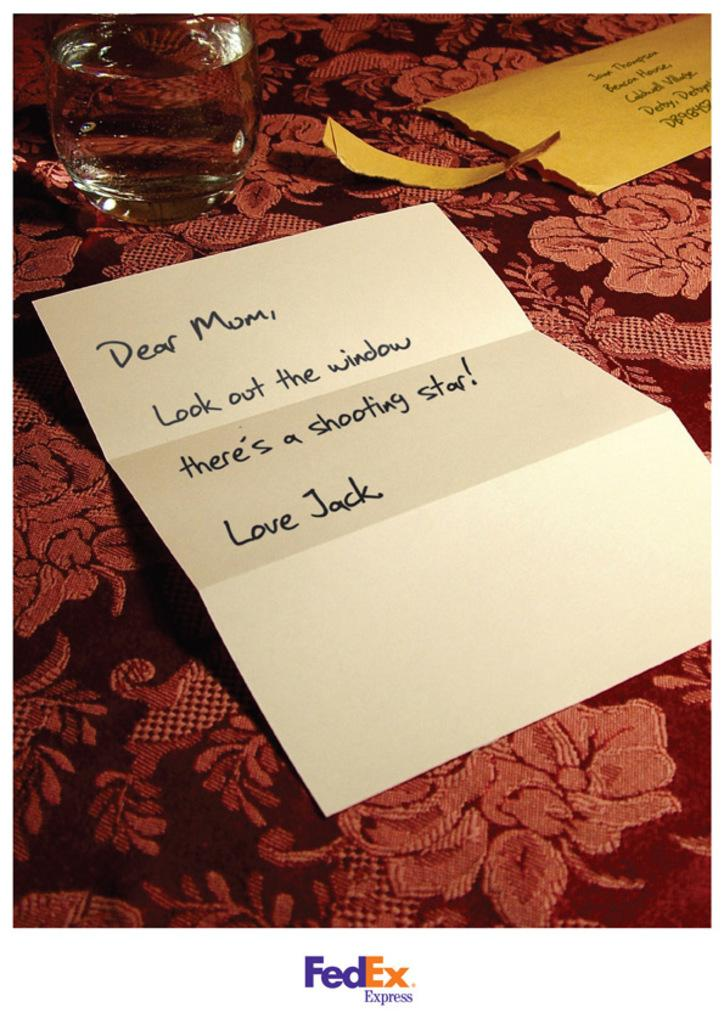What object is visible in the image that can hold liquids? There is a glass in the image that can hold liquids. What type of items are present on the cloth in the image? Papers are present on the cloth in the image. Can you describe the surface on which the papers are placed? The papers are on a cloth in the image. What type of tool is being used to plough the field in the image? There is no tool or field present in the image; it only contains a glass and papers on a cloth. 